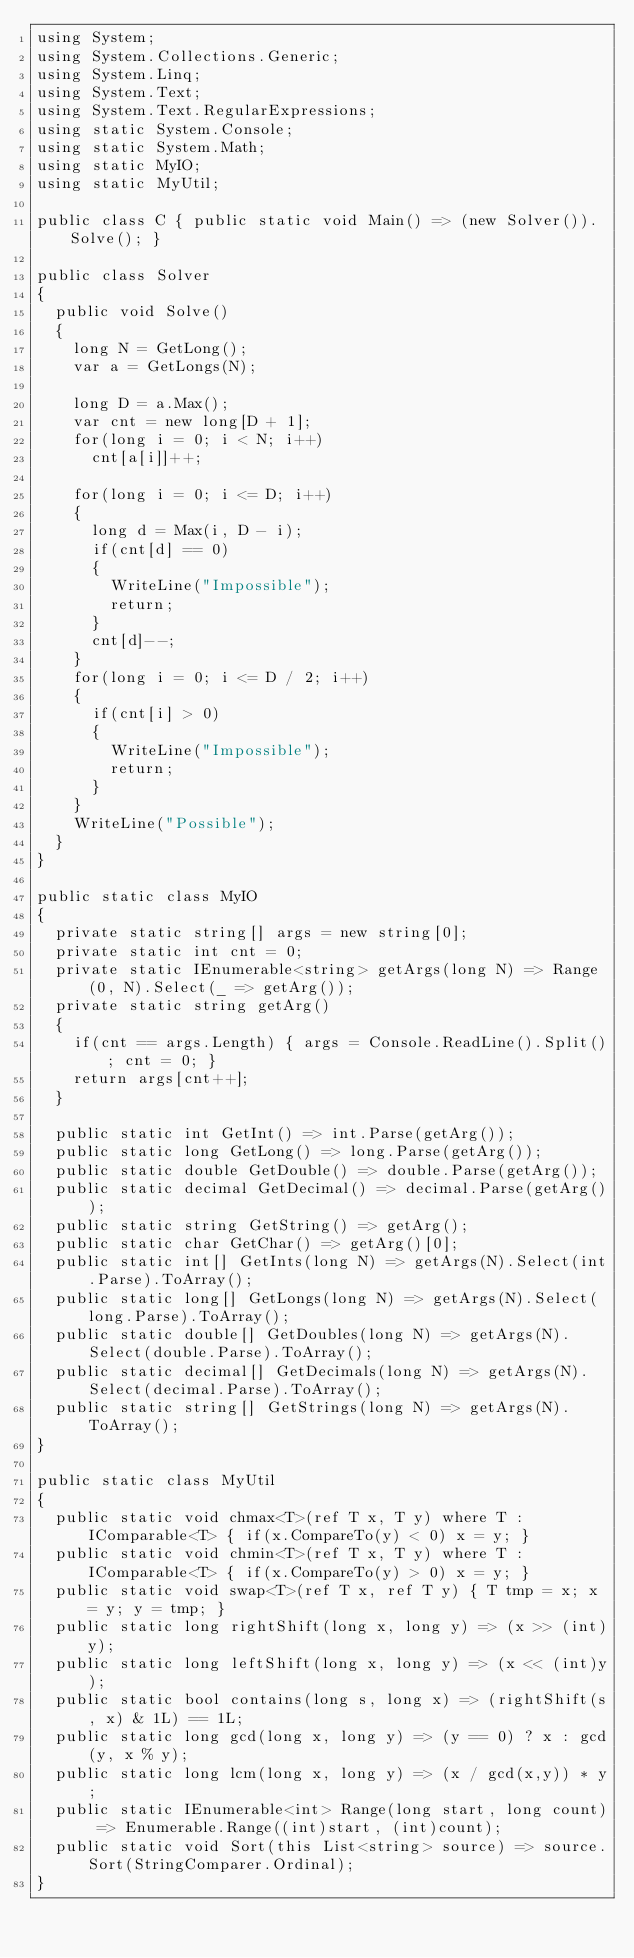<code> <loc_0><loc_0><loc_500><loc_500><_C#_>using System;
using System.Collections.Generic;
using System.Linq;
using System.Text;
using System.Text.RegularExpressions;
using static System.Console;
using static System.Math;
using static MyIO;
using static MyUtil;

public class C { public static void Main() => (new Solver()).Solve(); }

public class Solver
{
	public void Solve()
	{
		long N = GetLong();
		var a = GetLongs(N);

		long D = a.Max();
		var cnt = new long[D + 1];
		for(long i = 0; i < N; i++)
			cnt[a[i]]++;

		for(long i = 0; i <= D; i++)
		{
			long d = Max(i, D - i);
			if(cnt[d] == 0)
			{
				WriteLine("Impossible");
				return;
			}
			cnt[d]--;
		}
		for(long i = 0; i <= D / 2; i++)
		{
			if(cnt[i] > 0)
			{
				WriteLine("Impossible");
				return;
			}
		}
		WriteLine("Possible");
	}
}

public static class MyIO
{
	private static string[] args = new string[0];
	private static int cnt = 0;
	private static IEnumerable<string> getArgs(long N) => Range(0, N).Select(_ => getArg());
	private static string getArg()
	{
		if(cnt == args.Length) { args = Console.ReadLine().Split(); cnt = 0; }
		return args[cnt++];
	}

	public static int GetInt() => int.Parse(getArg());
	public static long GetLong() => long.Parse(getArg());
	public static double GetDouble() => double.Parse(getArg());
	public static decimal GetDecimal() => decimal.Parse(getArg());
	public static string GetString() => getArg();
	public static char GetChar() => getArg()[0];
	public static int[] GetInts(long N) => getArgs(N).Select(int.Parse).ToArray();
	public static long[] GetLongs(long N) => getArgs(N).Select(long.Parse).ToArray();
	public static double[] GetDoubles(long N) => getArgs(N).Select(double.Parse).ToArray();
	public static decimal[] GetDecimals(long N) => getArgs(N).Select(decimal.Parse).ToArray();
	public static string[] GetStrings(long N) => getArgs(N).ToArray();
}

public static class MyUtil
{
	public static void chmax<T>(ref T x, T y) where T : IComparable<T> { if(x.CompareTo(y) < 0) x = y; }
	public static void chmin<T>(ref T x, T y) where T : IComparable<T> { if(x.CompareTo(y) > 0)	x = y; }
	public static void swap<T>(ref T x, ref T y) { T tmp = x; x = y; y = tmp; }
	public static long rightShift(long x, long y) => (x >> (int)y);
	public static long leftShift(long x, long y) => (x << (int)y);
	public static bool contains(long s, long x) => (rightShift(s, x) & 1L) == 1L;
	public static long gcd(long x, long y) => (y == 0) ? x : gcd(y, x % y);
	public static long lcm(long x, long y) => (x / gcd(x,y)) * y;	
	public static IEnumerable<int> Range(long start, long count) => Enumerable.Range((int)start, (int)count);
	public static void Sort(this List<string> source) => source.Sort(StringComparer.Ordinal);
}
</code> 